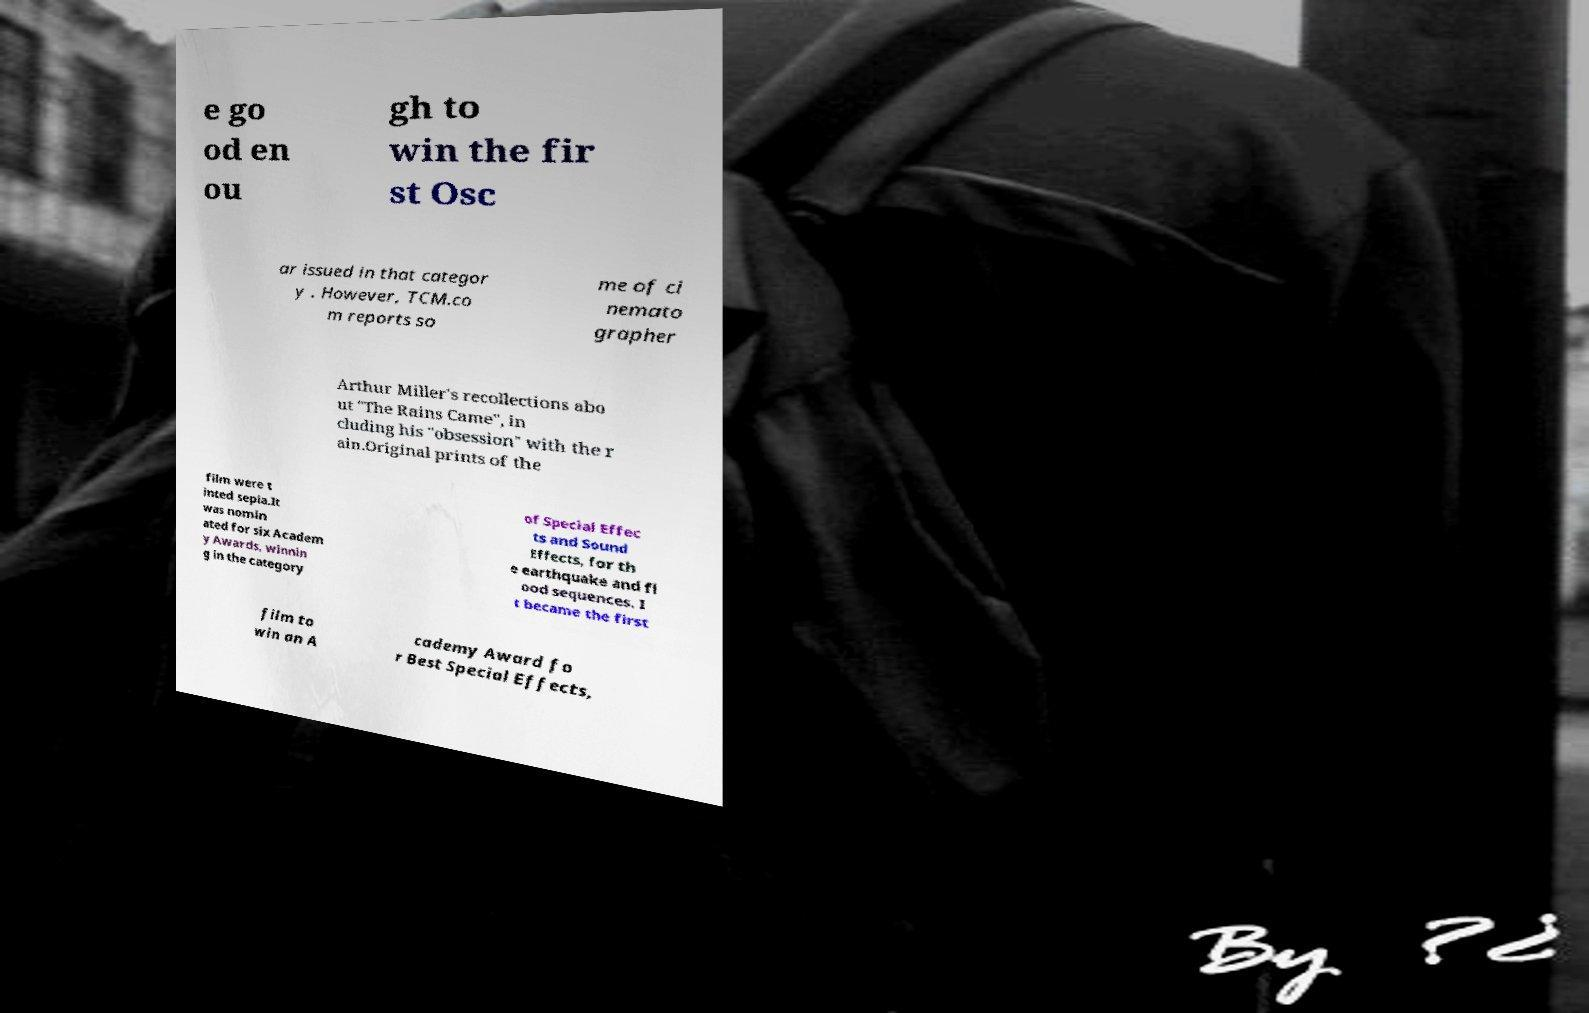What messages or text are displayed in this image? I need them in a readable, typed format. e go od en ou gh to win the fir st Osc ar issued in that categor y . However, TCM.co m reports so me of ci nemato grapher Arthur Miller's recollections abo ut "The Rains Came", in cluding his "obsession" with the r ain.Original prints of the film were t inted sepia.It was nomin ated for six Academ y Awards, winnin g in the category of Special Effec ts and Sound Effects, for th e earthquake and fl ood sequences. I t became the first film to win an A cademy Award fo r Best Special Effects, 